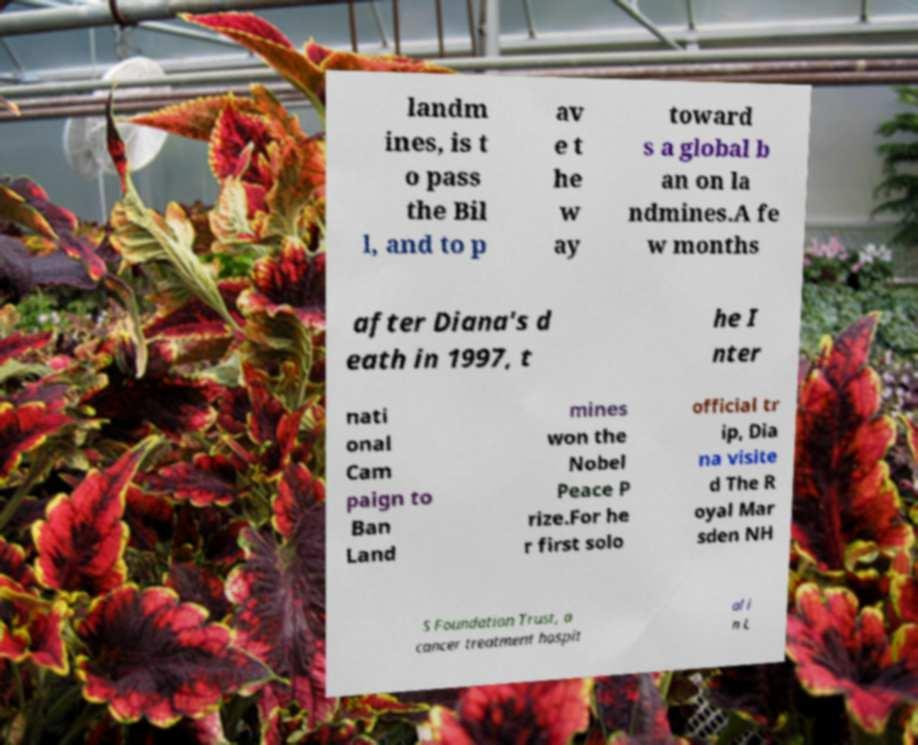There's text embedded in this image that I need extracted. Can you transcribe it verbatim? landm ines, is t o pass the Bil l, and to p av e t he w ay toward s a global b an on la ndmines.A fe w months after Diana's d eath in 1997, t he I nter nati onal Cam paign to Ban Land mines won the Nobel Peace P rize.For he r first solo official tr ip, Dia na visite d The R oyal Mar sden NH S Foundation Trust, a cancer treatment hospit al i n L 